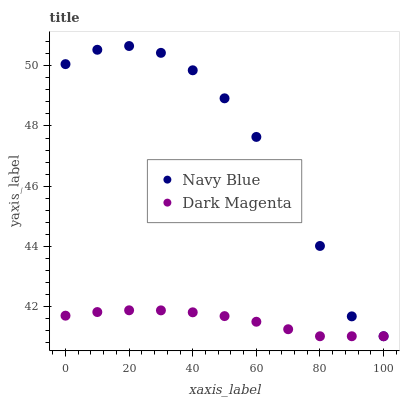Does Dark Magenta have the minimum area under the curve?
Answer yes or no. Yes. Does Navy Blue have the maximum area under the curve?
Answer yes or no. Yes. Does Dark Magenta have the maximum area under the curve?
Answer yes or no. No. Is Dark Magenta the smoothest?
Answer yes or no. Yes. Is Navy Blue the roughest?
Answer yes or no. Yes. Is Dark Magenta the roughest?
Answer yes or no. No. Does Navy Blue have the lowest value?
Answer yes or no. Yes. Does Navy Blue have the highest value?
Answer yes or no. Yes. Does Dark Magenta have the highest value?
Answer yes or no. No. Does Navy Blue intersect Dark Magenta?
Answer yes or no. Yes. Is Navy Blue less than Dark Magenta?
Answer yes or no. No. Is Navy Blue greater than Dark Magenta?
Answer yes or no. No. 